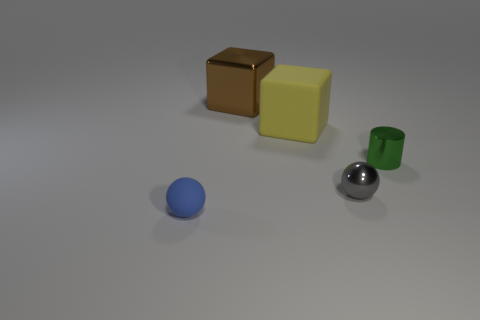How many cylinders are the same size as the brown cube?
Provide a short and direct response. 0. There is a large yellow object that is the same shape as the big brown metal thing; what material is it?
Ensure brevity in your answer.  Rubber. What number of objects are either small spheres behind the blue rubber object or tiny gray metal balls that are behind the blue matte thing?
Give a very brief answer. 1. There is a gray object; does it have the same shape as the rubber thing in front of the green thing?
Provide a succinct answer. Yes. What shape is the matte object that is on the left side of the matte thing that is behind the sphere that is left of the big brown metal object?
Your response must be concise. Sphere. What number of other things are there of the same material as the large yellow block
Keep it short and to the point. 1. What number of things are metallic objects that are in front of the green cylinder or big cylinders?
Your response must be concise. 1. There is a shiny object that is in front of the small green metallic cylinder behind the tiny blue sphere; what is its shape?
Your answer should be very brief. Sphere. There is a large object that is to the right of the brown metallic block; is it the same shape as the large brown object?
Your answer should be very brief. Yes. There is a small ball right of the small blue thing; what color is it?
Provide a succinct answer. Gray. 